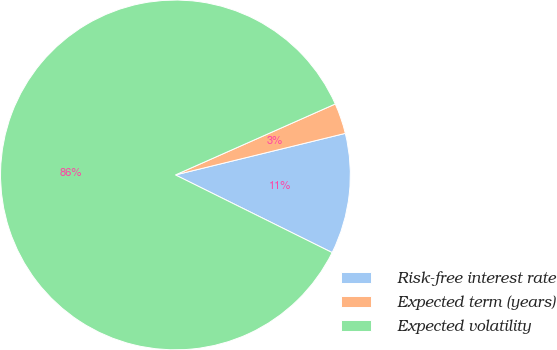Convert chart. <chart><loc_0><loc_0><loc_500><loc_500><pie_chart><fcel>Risk-free interest rate<fcel>Expected term (years)<fcel>Expected volatility<nl><fcel>11.14%<fcel>2.83%<fcel>86.03%<nl></chart> 